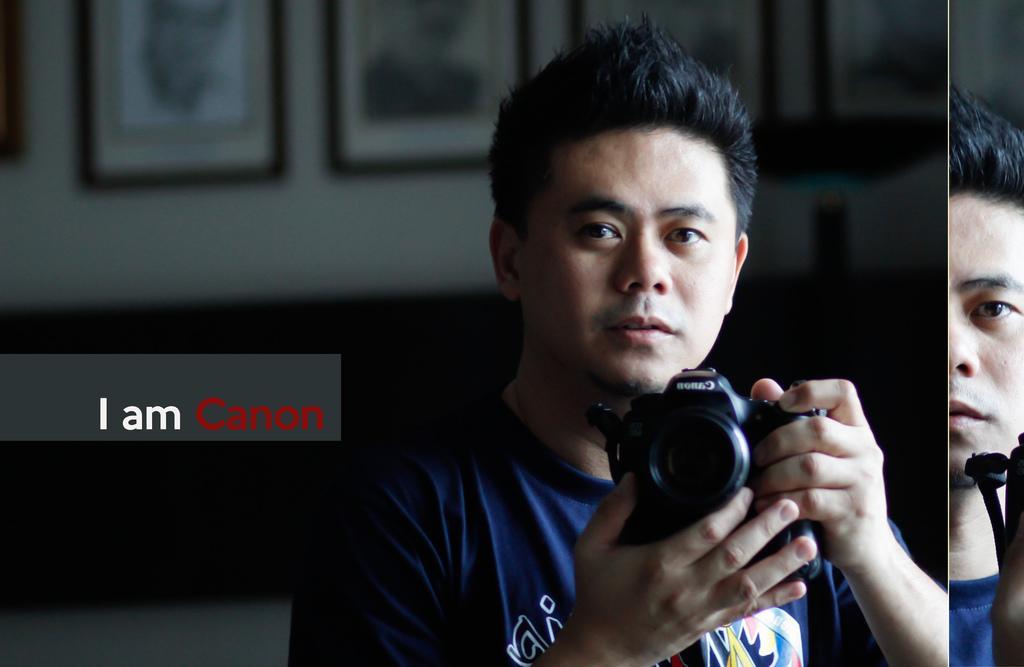Describe this image in one or two sentences. In this image there is a person wearing blue color T-shirt holding a camera in his hand and at the left side it is written as I'am canon 